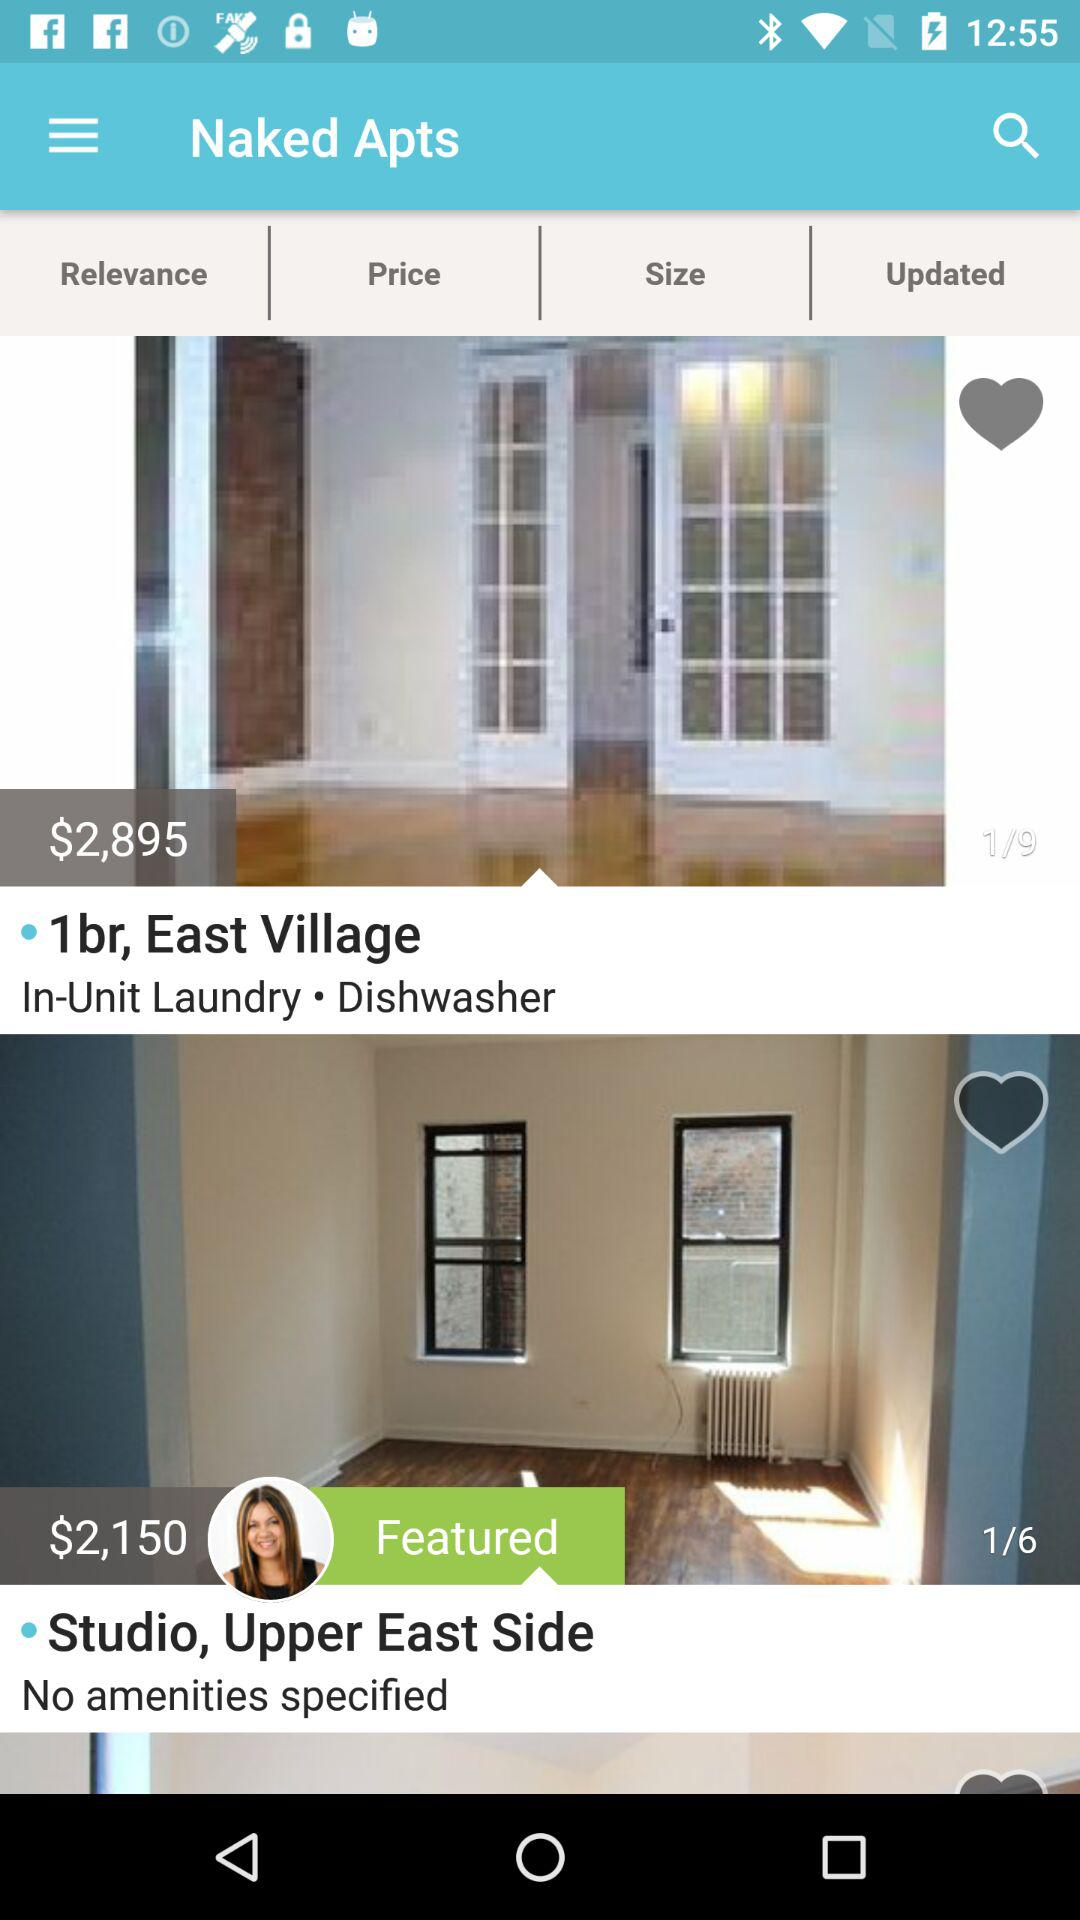What is the price of the one-bedroom apartment in "Naked Apts"? The price of the one-bedroom apartment in "Naked Apts" is $2,895. 